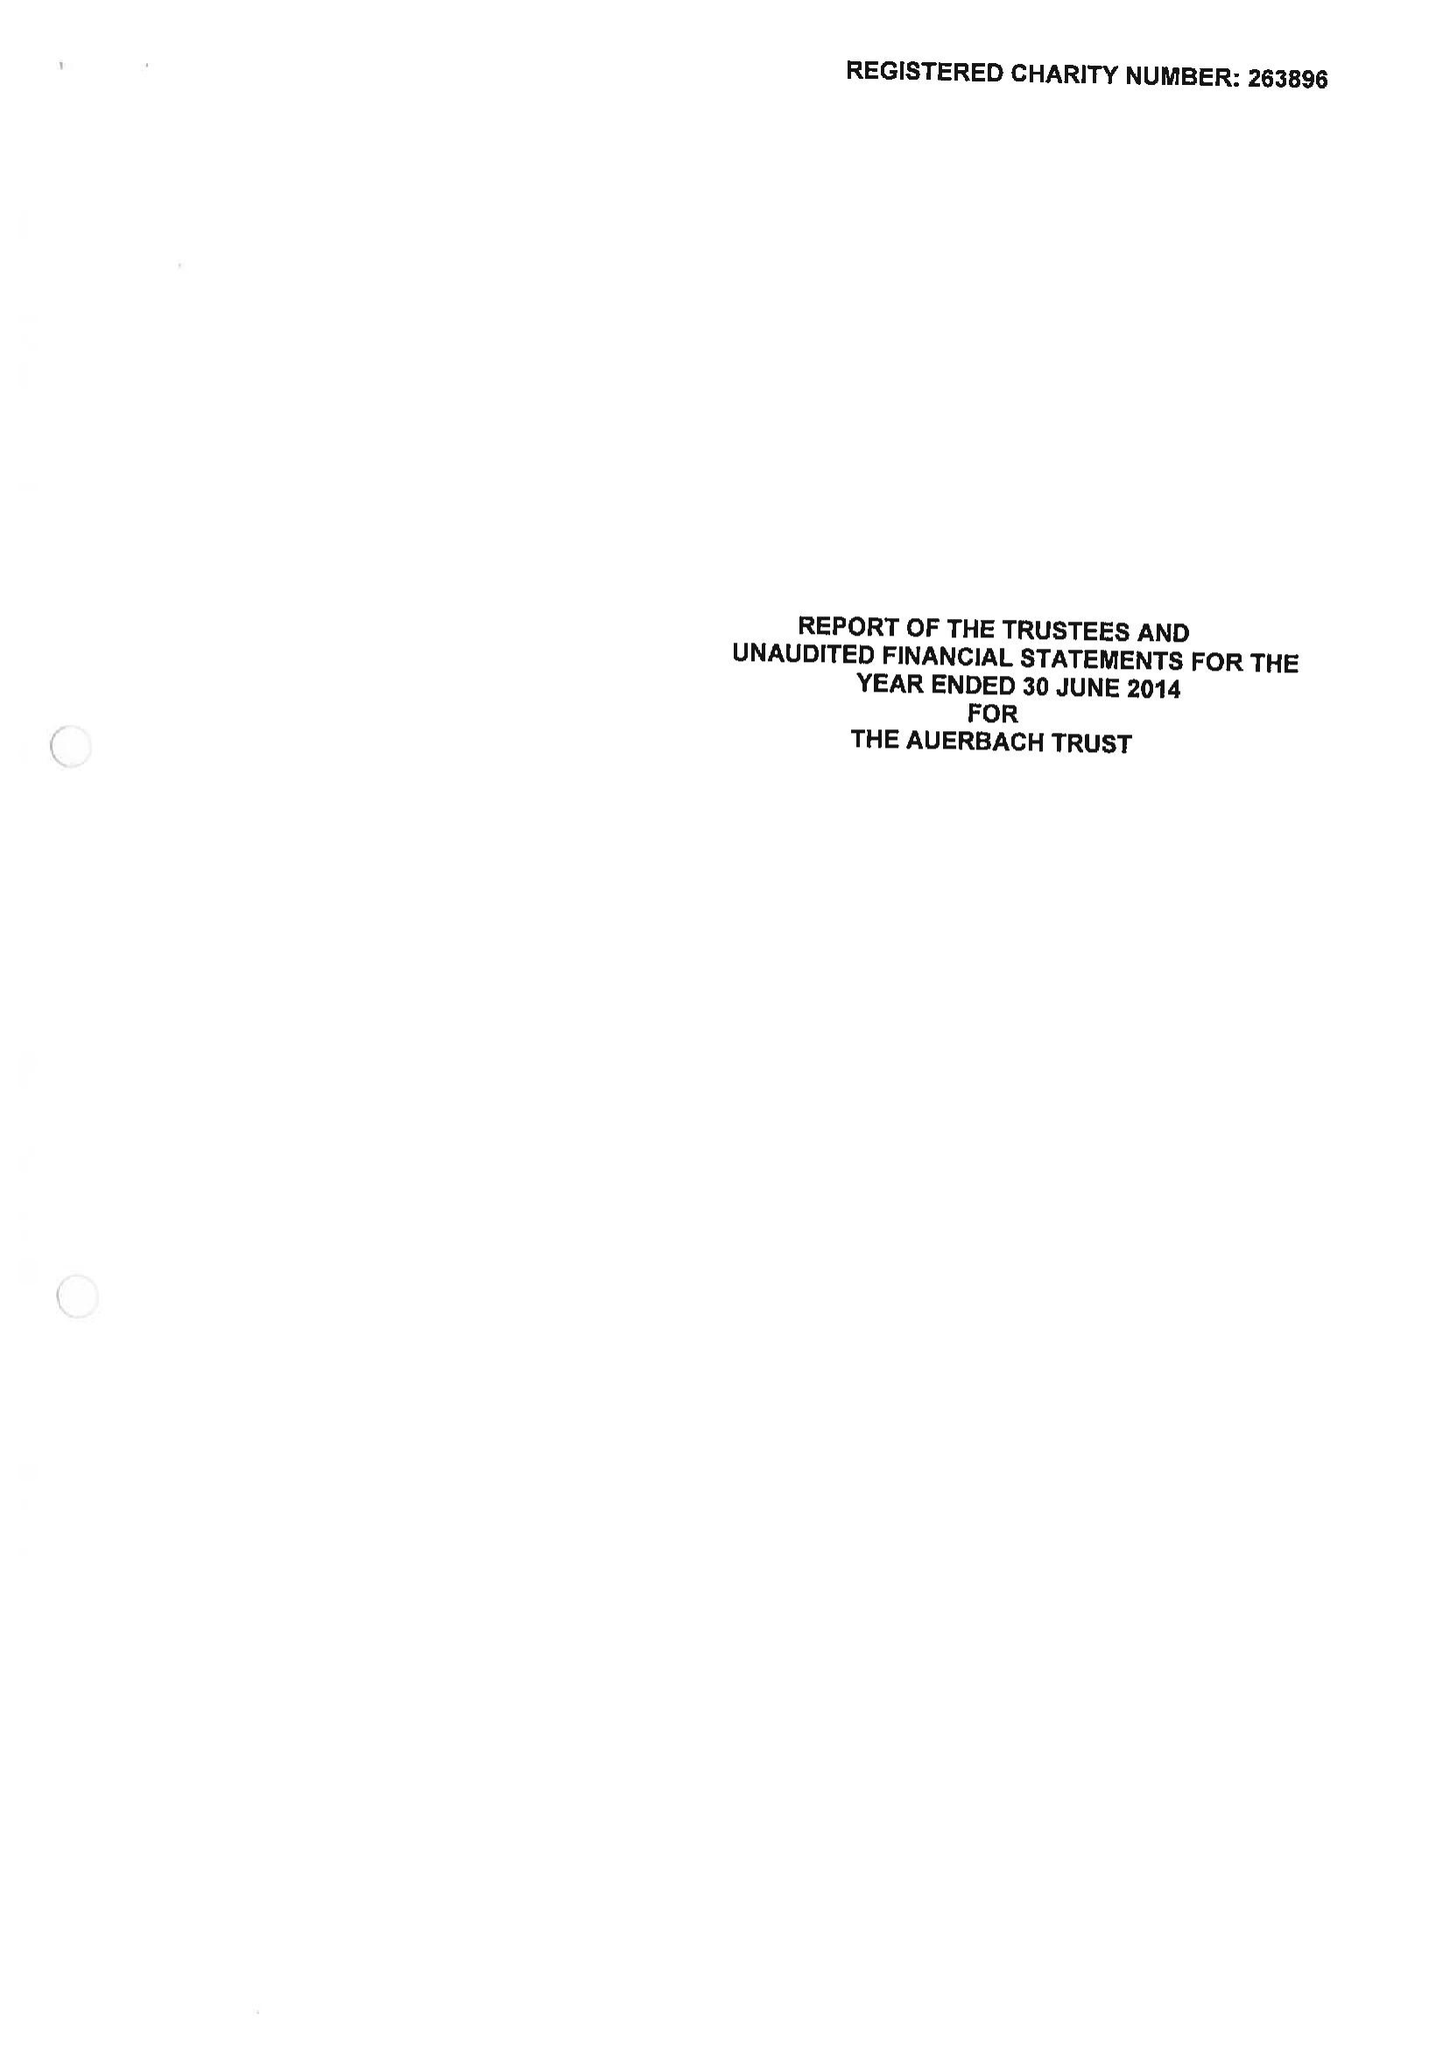What is the value for the address__postcode?
Answer the question using a single word or phrase. NW1 4RD 